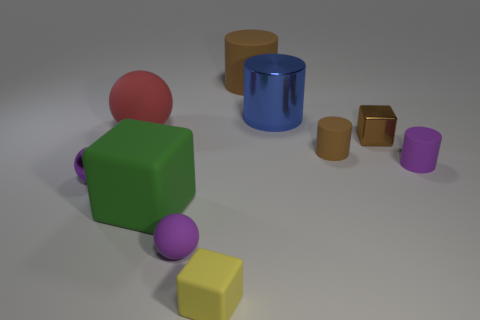Subtract all cylinders. How many objects are left? 6 Add 6 tiny purple rubber spheres. How many tiny purple rubber spheres are left? 7 Add 4 tiny brown rubber objects. How many tiny brown rubber objects exist? 5 Subtract 0 cyan balls. How many objects are left? 10 Subtract all large red rubber spheres. Subtract all brown cylinders. How many objects are left? 7 